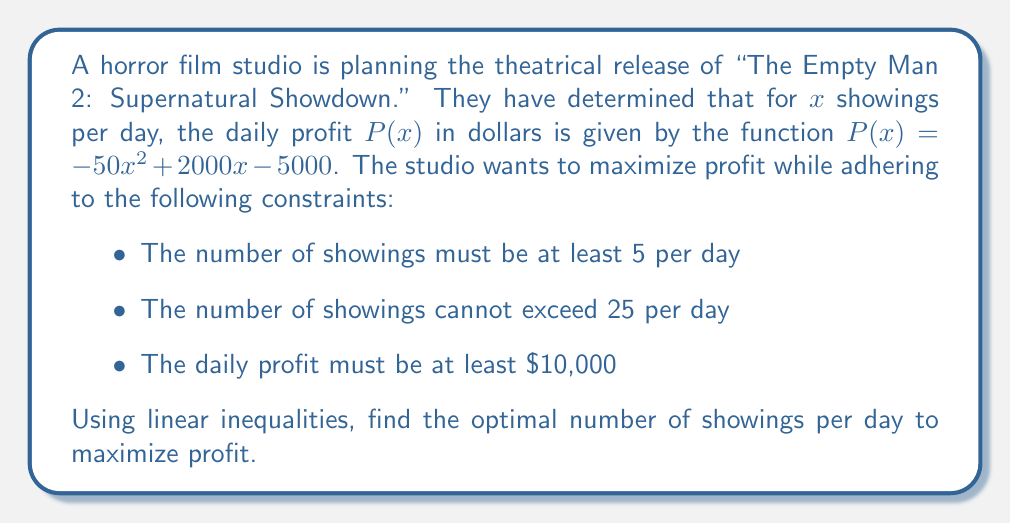Help me with this question. Let's approach this step-by-step:

1) First, we need to express our constraints as inequalities:
   $5 \leq x \leq 25$ (number of showings constraint)
   $P(x) \geq 10000$ (profit constraint)

2) For the profit constraint, we substitute the given function:
   $-50x^2 + 2000x - 5000 \geq 10000$

3) Simplify the inequality:
   $-50x^2 + 2000x - 15000 \geq 0$

4) This is a quadratic inequality. To solve it, we need to find the roots of the equation:
   $-50x^2 + 2000x - 15000 = 0$

5) Using the quadratic formula, $x = \frac{-b \pm \sqrt{b^2 - 4ac}}{2a}$, we get:
   $x = \frac{-2000 \pm \sqrt{2000^2 - 4(-50)(-15000)}}{2(-50)}$
   $x \approx 7.24$ or $x \approx 32.76$

6) Since the inequality is $\geq 0$, and the parabola opens downward (coefficient of $x^2$ is negative), the solution is:
   $7.24 \leq x \leq 32.76$

7) Combining this with our original constraints:
   $\max(5, 7.24) \leq x \leq \min(25, 32.76)$
   $7.24 \leq x \leq 25$

8) To maximize profit, we need to find the vertex of the parabola:
   $x = -\frac{b}{2a} = -\frac{2000}{2(-50)} = 20$

9) Since 20 is within our constraint range, this is our optimal number of showings.
Answer: 20 showings per day 